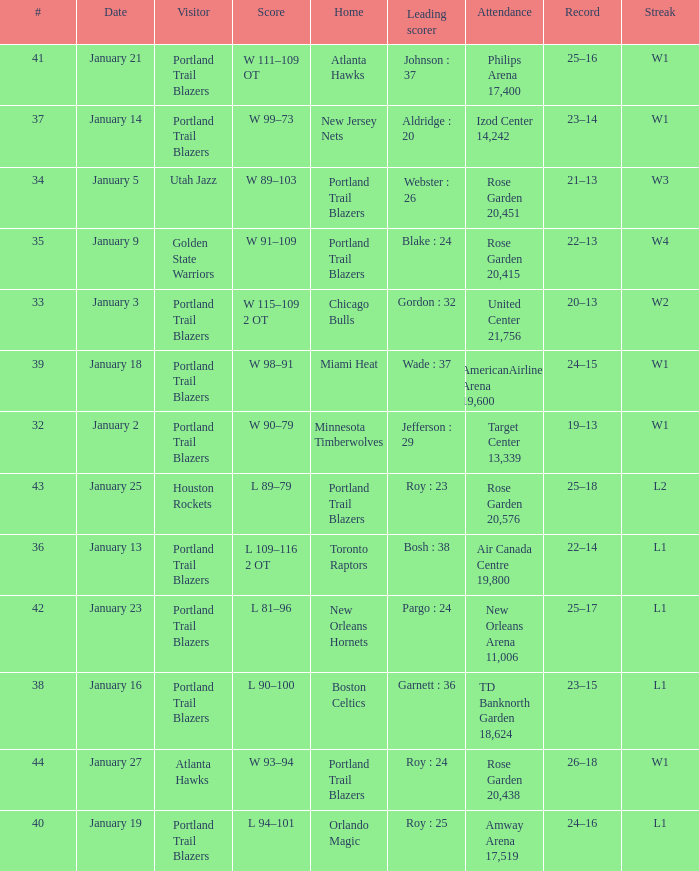What are all the records with a score is w 98–91 24–15. 